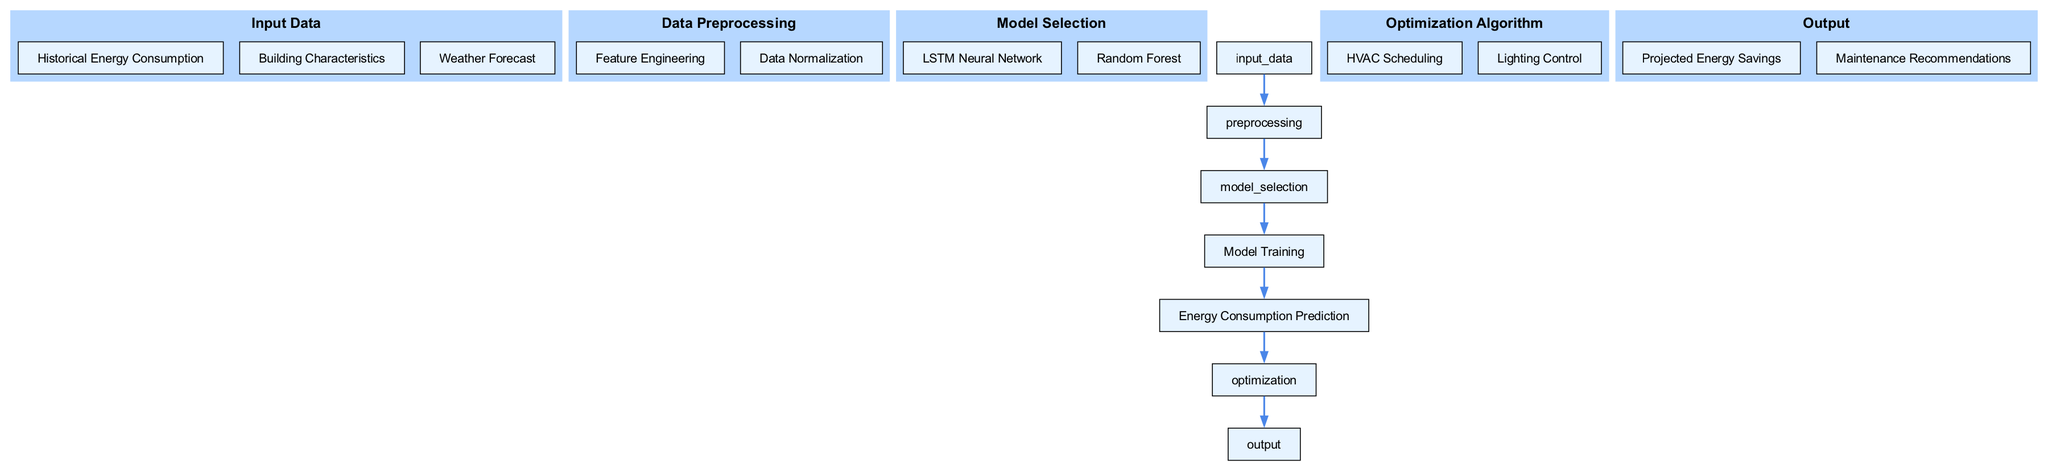What type of algorithm is used in model selection? The model selection node includes two children: an LSTM Neural Network and a Random Forest. Both of these are types of algorithms that can be used for forecasting tasks.
Answer: LSTM Neural Network, Random Forest How many nodes represent optimization actions? The optimization node has two children: HVAC Scheduling and Lighting Control, which represent the specific actions taken to optimize energy consumption. Therefore, there are two optimization actions represented.
Answer: 2 What is the final output of the diagram? The output of the diagram consists of two components: Projected Energy Savings and Maintenance Recommendations. Thus, the final outputs include tangible results based on predictions and optimizations performed earlier in the diagram flow.
Answer: Projected Energy Savings, Maintenance Recommendations What is the first step after input data? Once the input data is available, the next step is data preprocessing, which involves preparing the data for modeling through activities like feature engineering and normalization.
Answer: Data Preprocessing Which node comes before model training? The model training node follows the model selection node, which involves choosing an appropriate algorithm before initiating the training process. Therefore, the node that precedes model training is model selection.
Answer: Model Selection How do predictions influence optimization actions? The predictions generated from the energy consumption prediction node provide essential insights; these insights inform the optimization algorithm decisions, such as HVAC scheduling and lighting control. Thus, predictions directly lead to optimization actions being executed.
Answer: Optimization Algorithm What kind of data types are included in input data? The input data consists of three types: Historical Energy Consumption, Building Characteristics, and Weather Forecast. These diverse data types help create a comprehensive base for energy consumption forecasting.
Answer: Historical Energy Consumption, Building Characteristics, Weather Forecast Which component enhances the learning process of the model? The data preprocessing step includes feature engineering and normalization, both of which enhance the model's ability to learn effectively by improving the quality and consistency of the input data.
Answer: Feature Engineering, Data Normalization How many edges are in the diagram? There are six connections (or edges) that illustrate the flow of data from one step to the next between input data, preprocessing, model selection, training, prediction, optimization, and output.
Answer: 6 